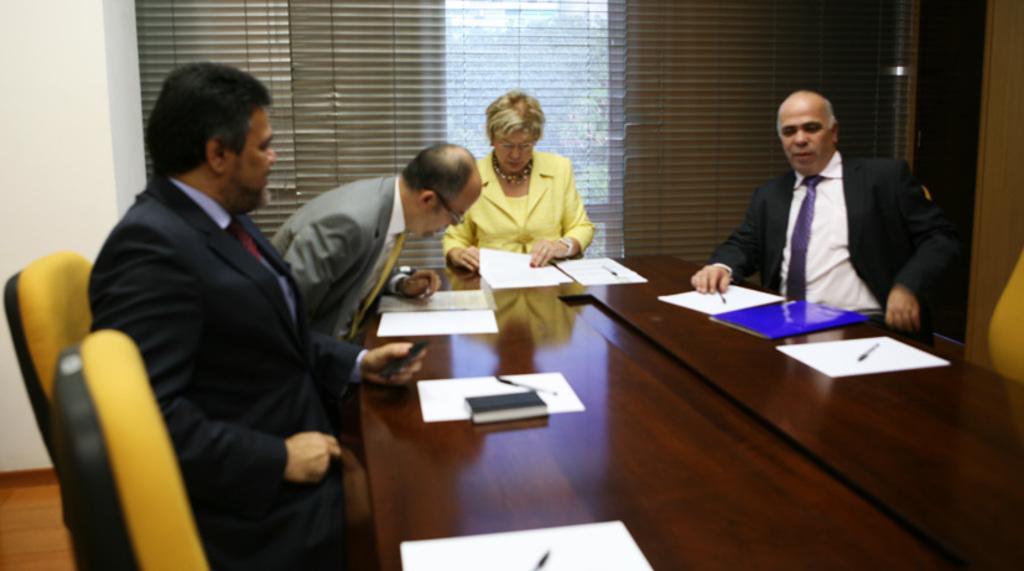How would you summarize this image in a sentence or two? These persons are sitting on a chair, In-front of this person's there is a table, on a table there is a book, papers and pen. Backside of this woman there is a window. 